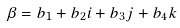Convert formula to latex. <formula><loc_0><loc_0><loc_500><loc_500>\beta = b _ { 1 } + b _ { 2 } i + b _ { 3 } j + b _ { 4 } k</formula> 